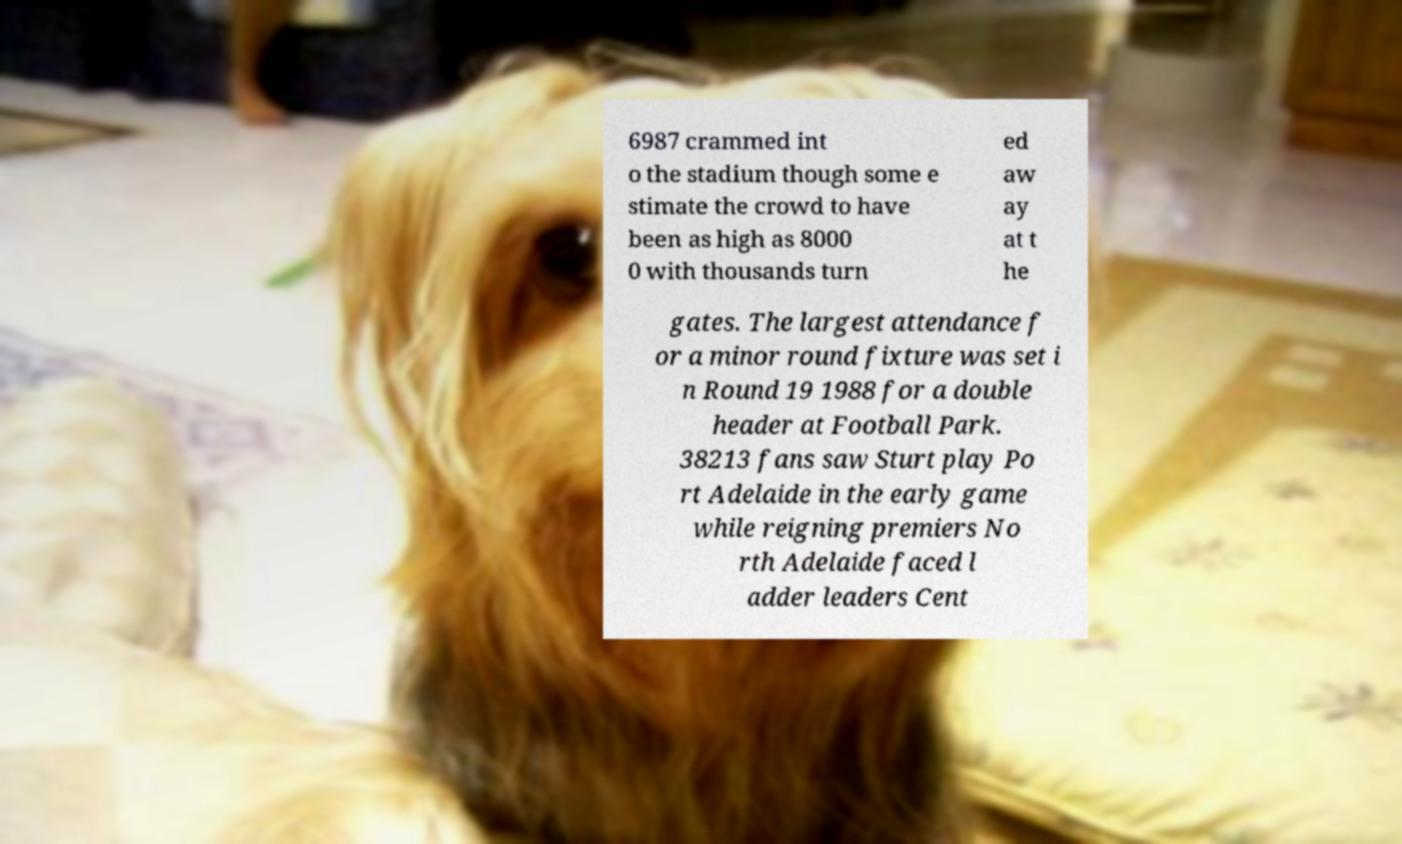Can you accurately transcribe the text from the provided image for me? 6987 crammed int o the stadium though some e stimate the crowd to have been as high as 8000 0 with thousands turn ed aw ay at t he gates. The largest attendance f or a minor round fixture was set i n Round 19 1988 for a double header at Football Park. 38213 fans saw Sturt play Po rt Adelaide in the early game while reigning premiers No rth Adelaide faced l adder leaders Cent 